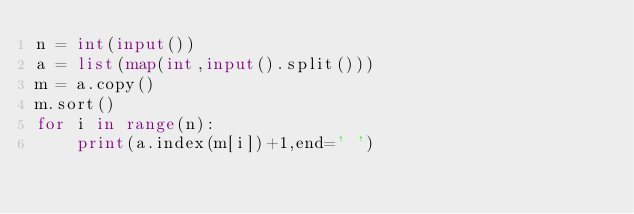Convert code to text. <code><loc_0><loc_0><loc_500><loc_500><_Python_>n = int(input())
a = list(map(int,input().split()))
m = a.copy()
m.sort()
for i in range(n):
    print(a.index(m[i])+1,end=' ')


</code> 